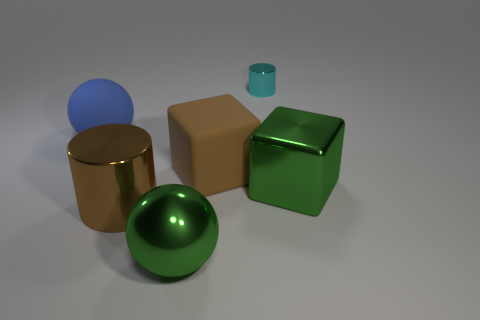Add 3 big rubber objects. How many objects exist? 9 Subtract all cylinders. How many objects are left? 4 Add 6 brown shiny objects. How many brown shiny objects exist? 7 Subtract 0 red spheres. How many objects are left? 6 Subtract all cyan metal objects. Subtract all brown matte objects. How many objects are left? 4 Add 4 big green things. How many big green things are left? 6 